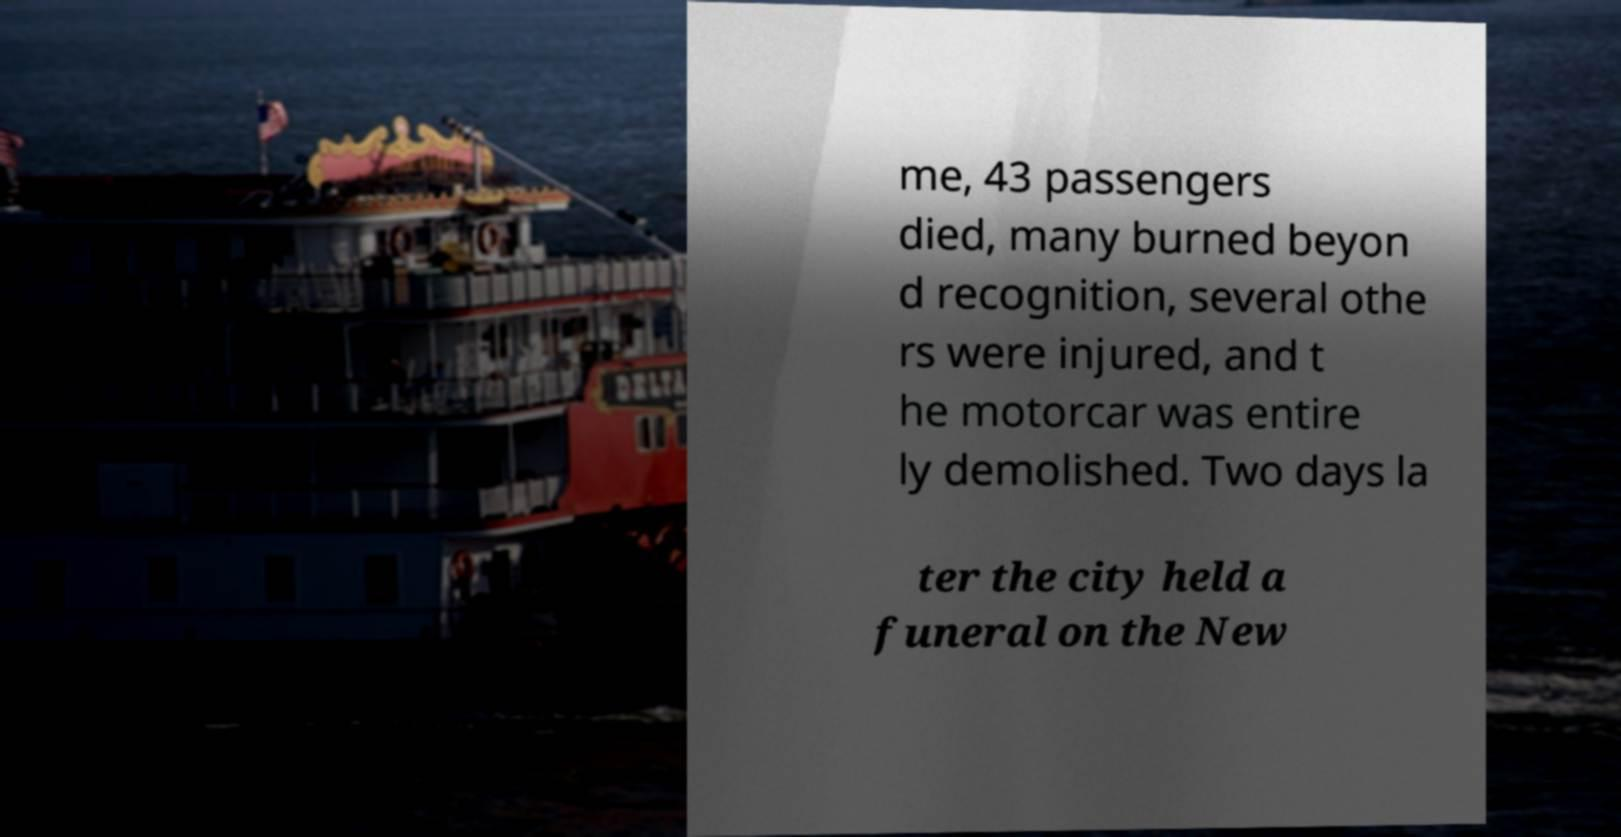Could you assist in decoding the text presented in this image and type it out clearly? me, 43 passengers died, many burned beyon d recognition, several othe rs were injured, and t he motorcar was entire ly demolished. Two days la ter the city held a funeral on the New 